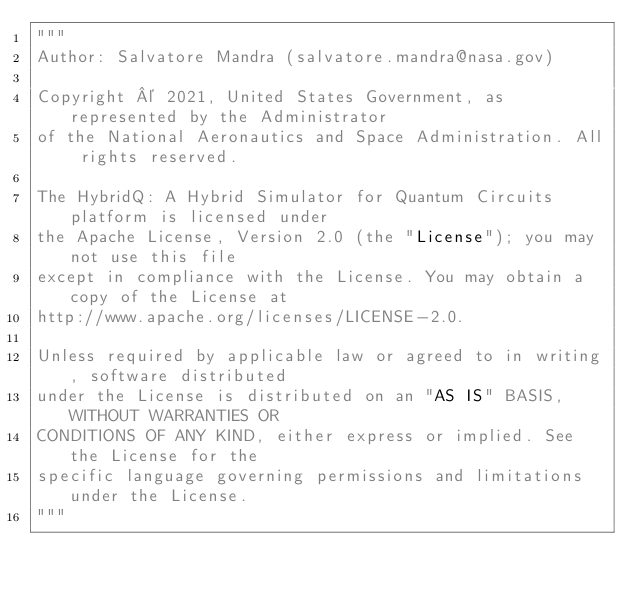<code> <loc_0><loc_0><loc_500><loc_500><_Python_>"""
Author: Salvatore Mandra (salvatore.mandra@nasa.gov)

Copyright © 2021, United States Government, as represented by the Administrator
of the National Aeronautics and Space Administration. All rights reserved.

The HybridQ: A Hybrid Simulator for Quantum Circuits platform is licensed under
the Apache License, Version 2.0 (the "License"); you may not use this file
except in compliance with the License. You may obtain a copy of the License at
http://www.apache.org/licenses/LICENSE-2.0.

Unless required by applicable law or agreed to in writing, software distributed
under the License is distributed on an "AS IS" BASIS, WITHOUT WARRANTIES OR
CONDITIONS OF ANY KIND, either express or implied. See the License for the
specific language governing permissions and limitations under the License.
"""
</code> 